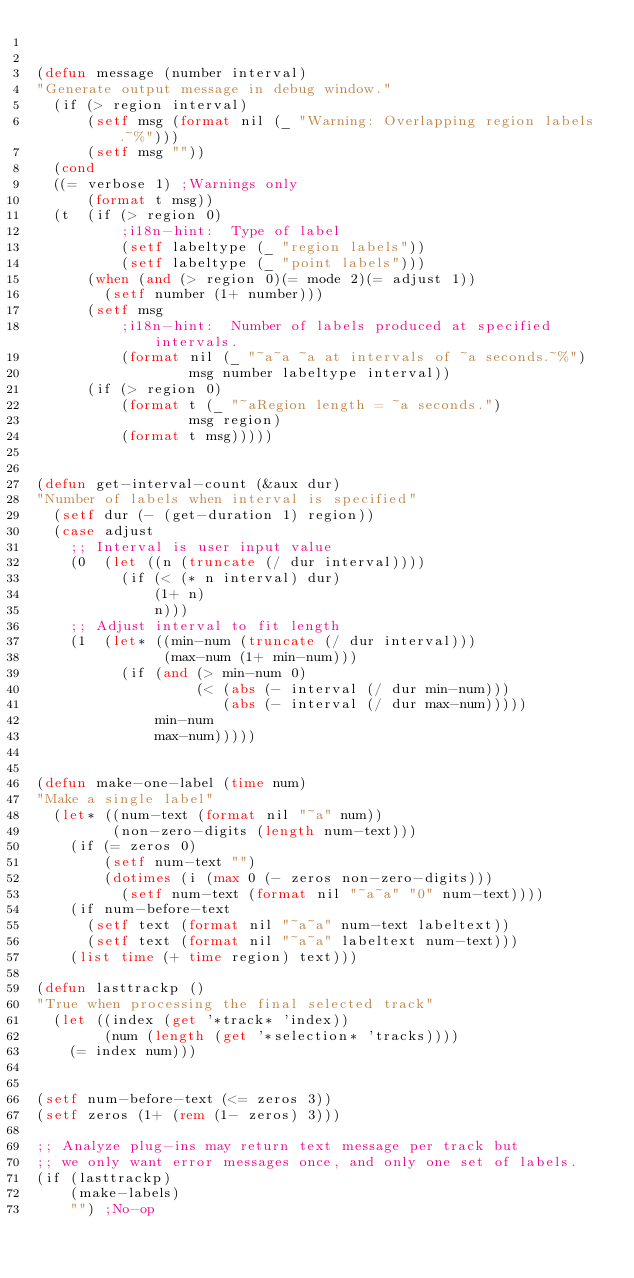<code> <loc_0><loc_0><loc_500><loc_500><_Lisp_>

(defun message (number interval)
"Generate output message in debug window."
  (if (> region interval)
      (setf msg (format nil (_ "Warning: Overlapping region labels.~%")))
      (setf msg ""))
  (cond
  ((= verbose 1) ;Warnings only
      (format t msg))
  (t  (if (> region 0)
          ;i18n-hint:  Type of label
          (setf labeltype (_ "region labels"))
          (setf labeltype (_ "point labels")))
      (when (and (> region 0)(= mode 2)(= adjust 1))
        (setf number (1+ number)))
      (setf msg
          ;i18n-hint:  Number of labels produced at specified intervals.
          (format nil (_ "~a~a ~a at intervals of ~a seconds.~%")
                  msg number labeltype interval))
      (if (> region 0)
          (format t (_ "~aRegion length = ~a seconds.")
                  msg region)
          (format t msg)))))


(defun get-interval-count (&aux dur)
"Number of labels when interval is specified"
  (setf dur (- (get-duration 1) region))
  (case adjust
    ;; Interval is user input value
    (0  (let ((n (truncate (/ dur interval))))
          (if (< (* n interval) dur)
              (1+ n)
              n)))
    ;; Adjust interval to fit length
    (1  (let* ((min-num (truncate (/ dur interval)))
               (max-num (1+ min-num)))
          (if (and (> min-num 0)
                   (< (abs (- interval (/ dur min-num)))
                      (abs (- interval (/ dur max-num)))))
              min-num
              max-num)))))


(defun make-one-label (time num)
"Make a single label"
  (let* ((num-text (format nil "~a" num))
         (non-zero-digits (length num-text)))
    (if (= zeros 0)
        (setf num-text "")
        (dotimes (i (max 0 (- zeros non-zero-digits)))
          (setf num-text (format nil "~a~a" "0" num-text))))
    (if num-before-text
      (setf text (format nil "~a~a" num-text labeltext))
      (setf text (format nil "~a~a" labeltext num-text)))
    (list time (+ time region) text)))

(defun lasttrackp ()
"True when processing the final selected track"
  (let ((index (get '*track* 'index))
        (num (length (get '*selection* 'tracks))))
    (= index num)))


(setf num-before-text (<= zeros 3))
(setf zeros (1+ (rem (1- zeros) 3)))

;; Analyze plug-ins may return text message per track but
;; we only want error messages once, and only one set of labels.
(if (lasttrackp)
    (make-labels)
    "") ;No-op
</code> 